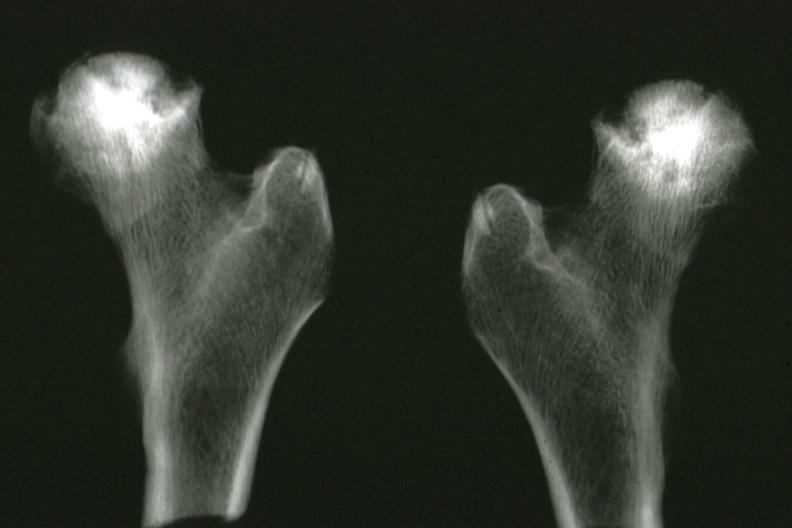how is x-ray of femoral heads removed at autopsy illustration?
Answer the question using a single word or phrase. Good 